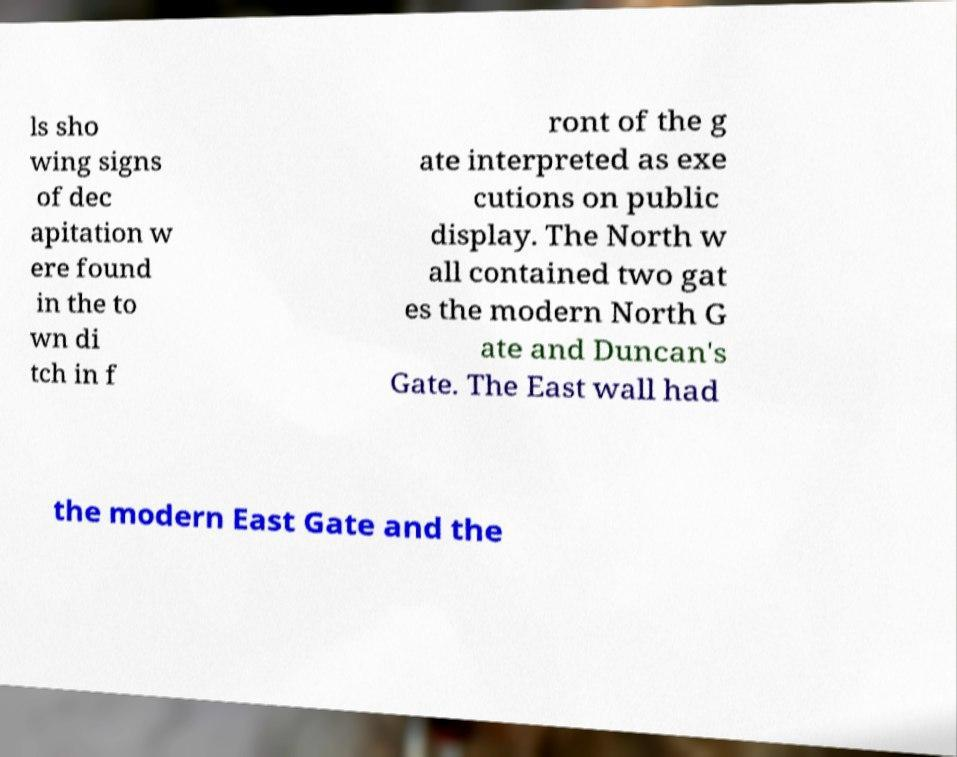Please identify and transcribe the text found in this image. ls sho wing signs of dec apitation w ere found in the to wn di tch in f ront of the g ate interpreted as exe cutions on public display. The North w all contained two gat es the modern North G ate and Duncan's Gate. The East wall had the modern East Gate and the 